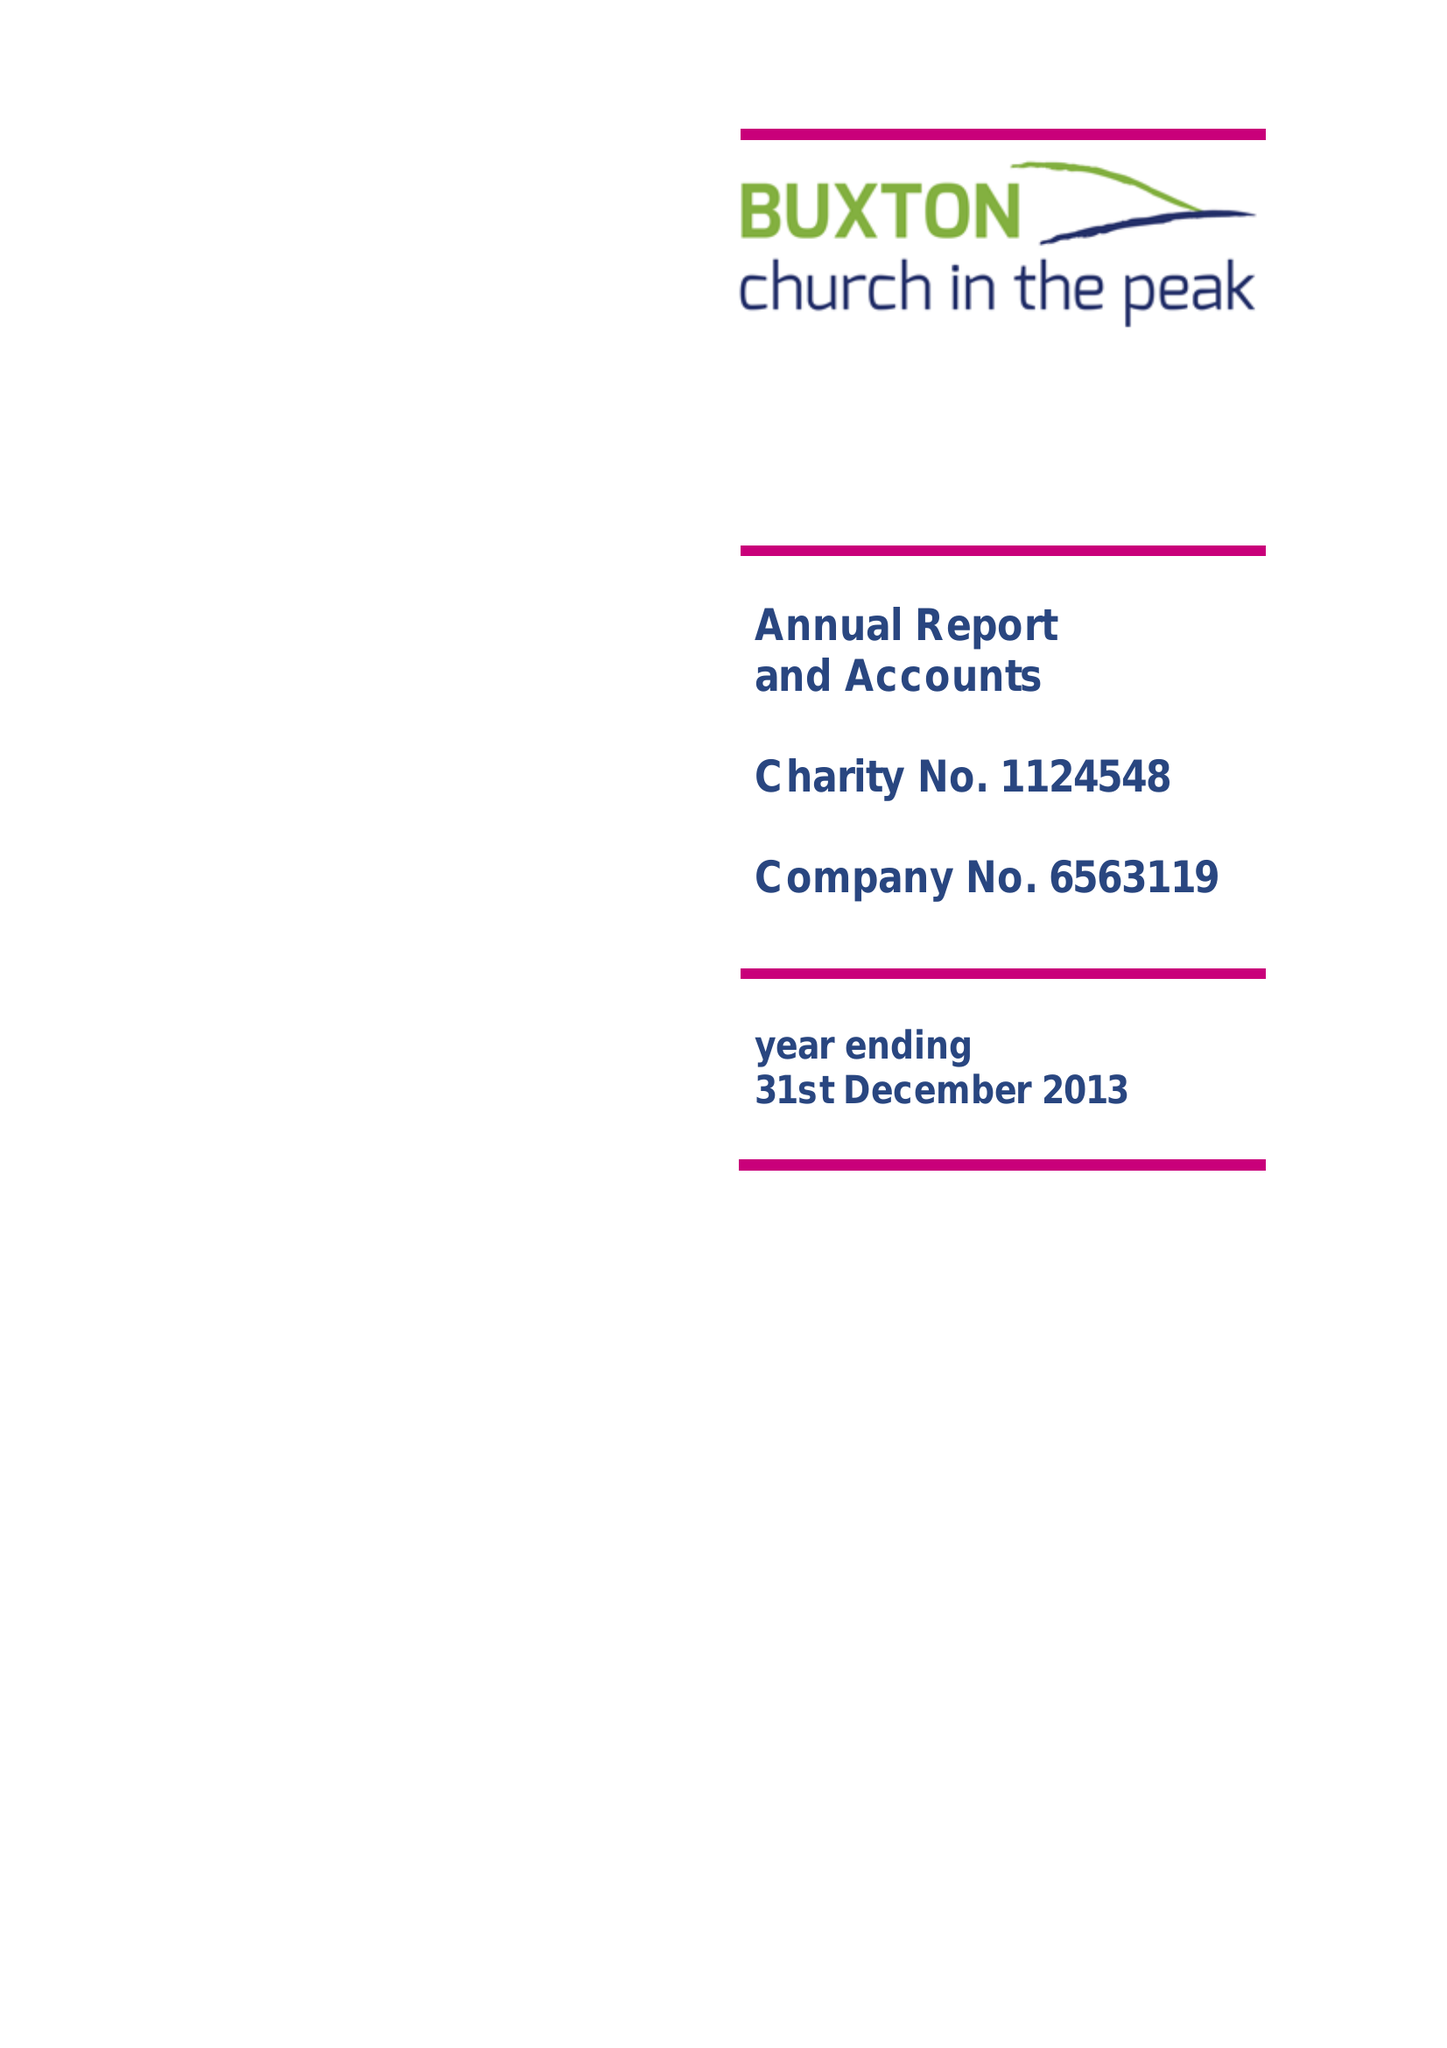What is the value for the charity_number?
Answer the question using a single word or phrase. 1124548 